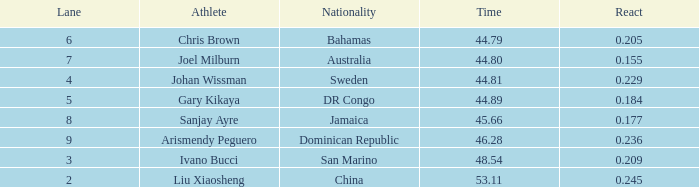How many entire time listings possess a 0.0. 